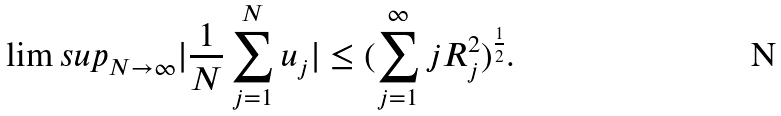Convert formula to latex. <formula><loc_0><loc_0><loc_500><loc_500>\lim s u p _ { N \to \infty } | \frac { 1 } { N } \sum _ { j = 1 } ^ { N } u _ { j } | \leq ( \sum _ { j = 1 } ^ { \infty } j R _ { j } ^ { 2 } ) ^ { \frac { 1 } { 2 } } .</formula> 